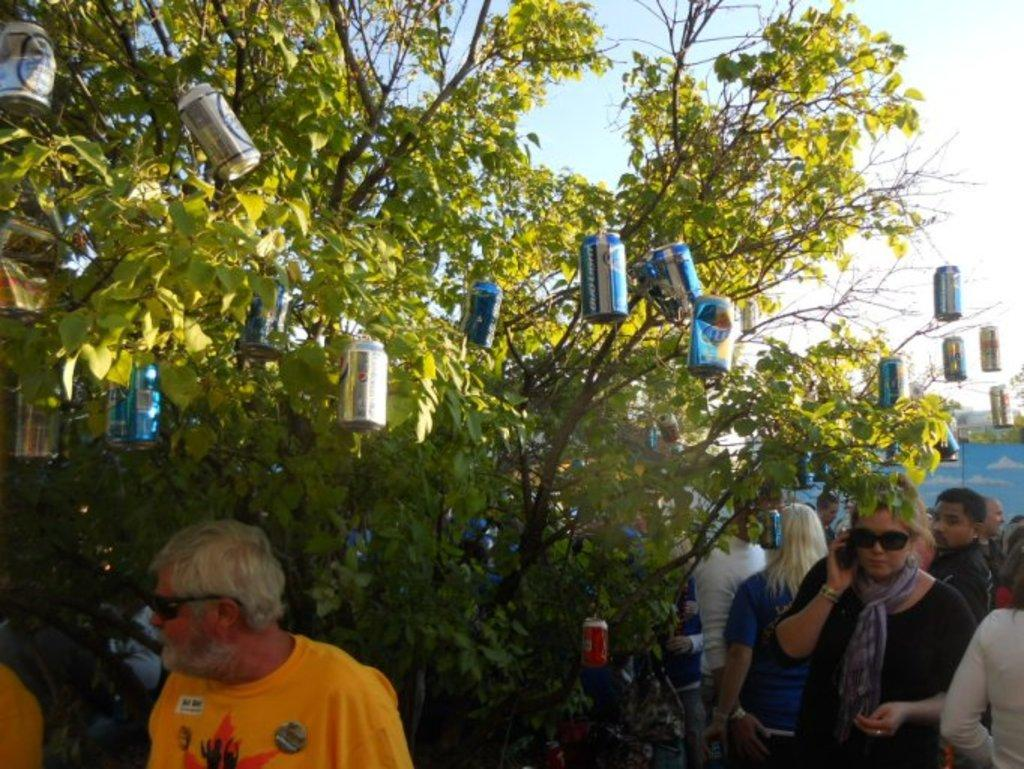What is hanging from the stems of the tree in the image? There are cock-tins hanging from the stems of a tree in the image. What can be seen at the bottom of the image? There is a crowd of people at the bottom of the image. What is visible at the top of the image? The sky is visible at the top of the image. What type of club is being used by the people in the image? There is no club visible in the image; it features cock-tins hanging from a tree and a crowd of people at the bottom. What unit is responsible for organizing the event in the image? There is no event or unit mentioned in the image; it only shows cock-tins hanging from a tree and a crowd of people. 